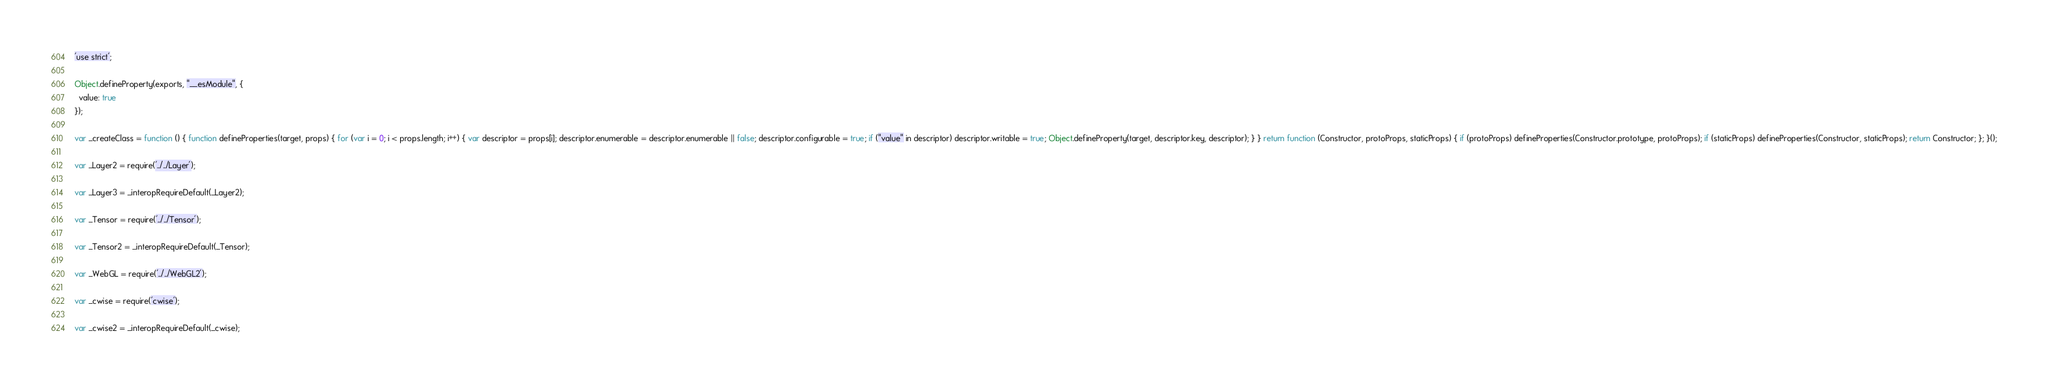<code> <loc_0><loc_0><loc_500><loc_500><_JavaScript_>'use strict';

Object.defineProperty(exports, "__esModule", {
  value: true
});

var _createClass = function () { function defineProperties(target, props) { for (var i = 0; i < props.length; i++) { var descriptor = props[i]; descriptor.enumerable = descriptor.enumerable || false; descriptor.configurable = true; if ("value" in descriptor) descriptor.writable = true; Object.defineProperty(target, descriptor.key, descriptor); } } return function (Constructor, protoProps, staticProps) { if (protoProps) defineProperties(Constructor.prototype, protoProps); if (staticProps) defineProperties(Constructor, staticProps); return Constructor; }; }();

var _Layer2 = require('../../Layer');

var _Layer3 = _interopRequireDefault(_Layer2);

var _Tensor = require('../../Tensor');

var _Tensor2 = _interopRequireDefault(_Tensor);

var _WebGL = require('../../WebGL2');

var _cwise = require('cwise');

var _cwise2 = _interopRequireDefault(_cwise);
</code> 